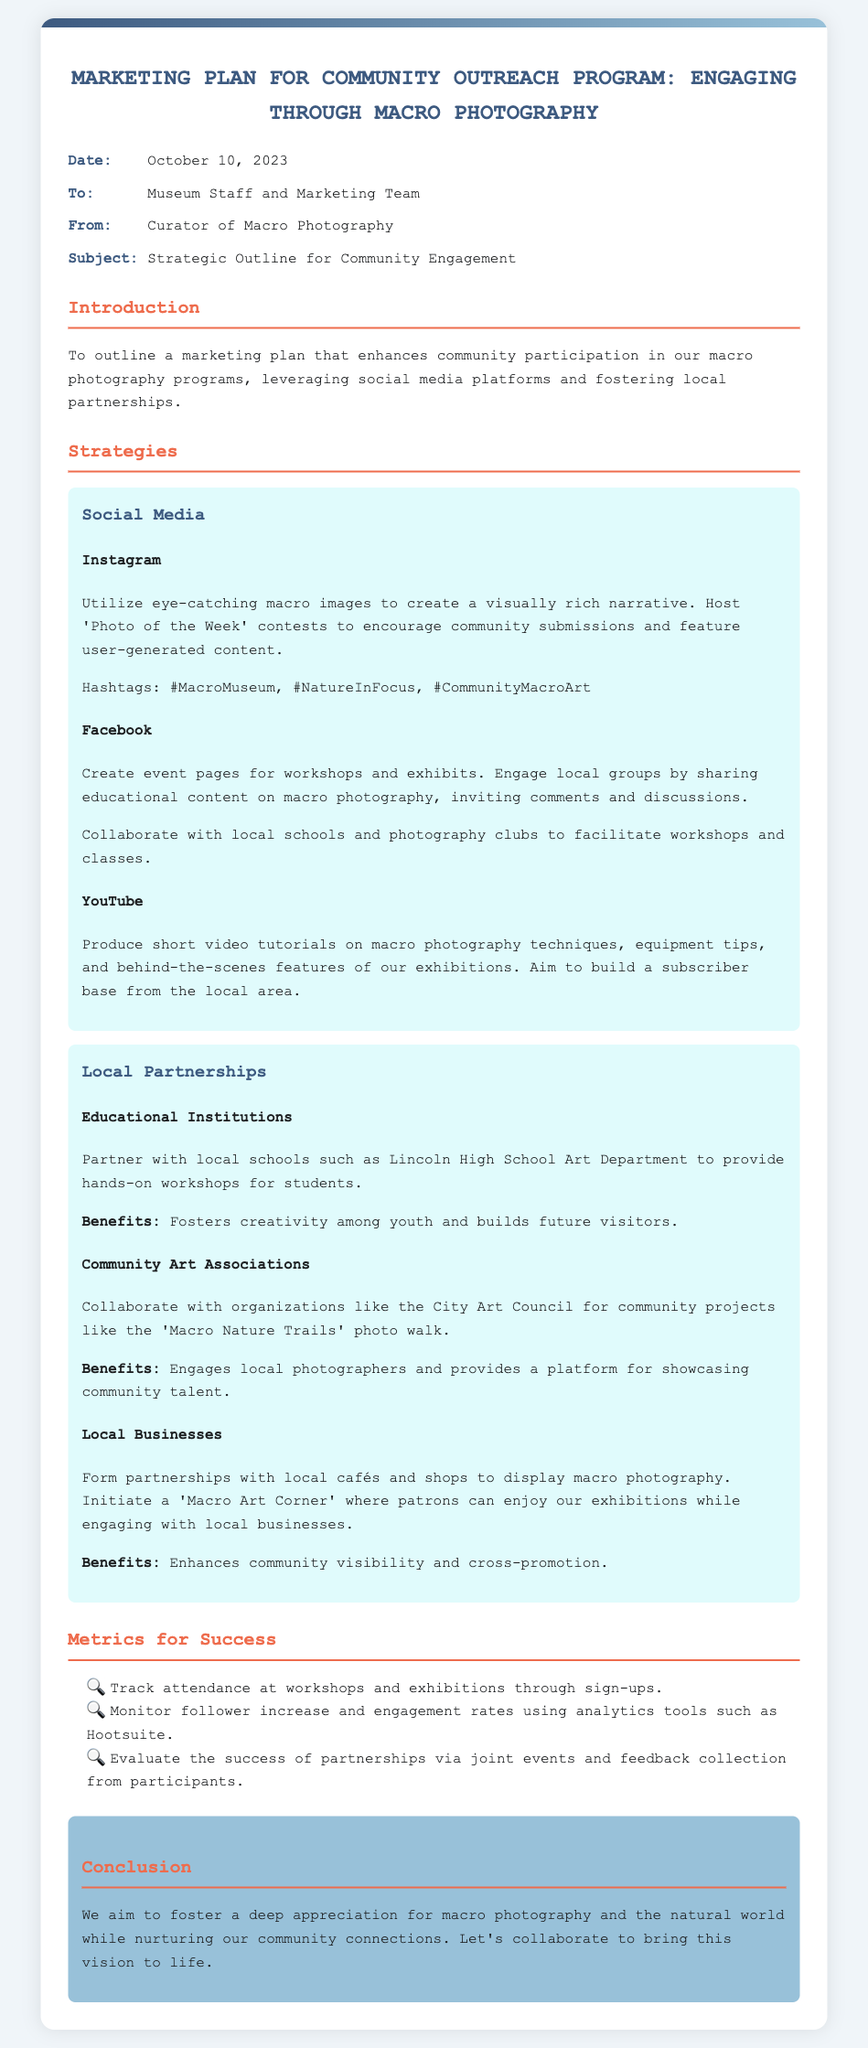What is the date of the memo? The date of the memo is stated at the top of the document under the 'Date' section.
Answer: October 10, 2023 Who is the memo addressed to? The 'To' section of the memo specifies the recipients of the document.
Answer: Museum Staff and Marketing Team What is the subject of the memo? The 'Subject' section of the memo provides the main focus of the communication.
Answer: Strategic Outline for Community Engagement What social media platform is mentioned first in the strategies? The first social media platform listed in the strategy section is specified under the 'Social Media' header.
Answer: Instagram What organization is suggested for partnership regarding community projects? The document lists specific organizations for partnerships under the 'Local Partnerships' section.
Answer: City Art Council How many metrics for success are mentioned? The number of metrics for success can be counted from the 'Metrics for Success' section in the document.
Answer: Three What workshop is suggested for Lincoln High School? The specific workshop mentioned in the document relates to a potential partnership with a local school.
Answer: Hands-on workshops What is the primary goal of this marketing plan? The main objective of the marketing plan can be inferred from the introductory paragraphs of the memo.
Answer: Enhance community participation 